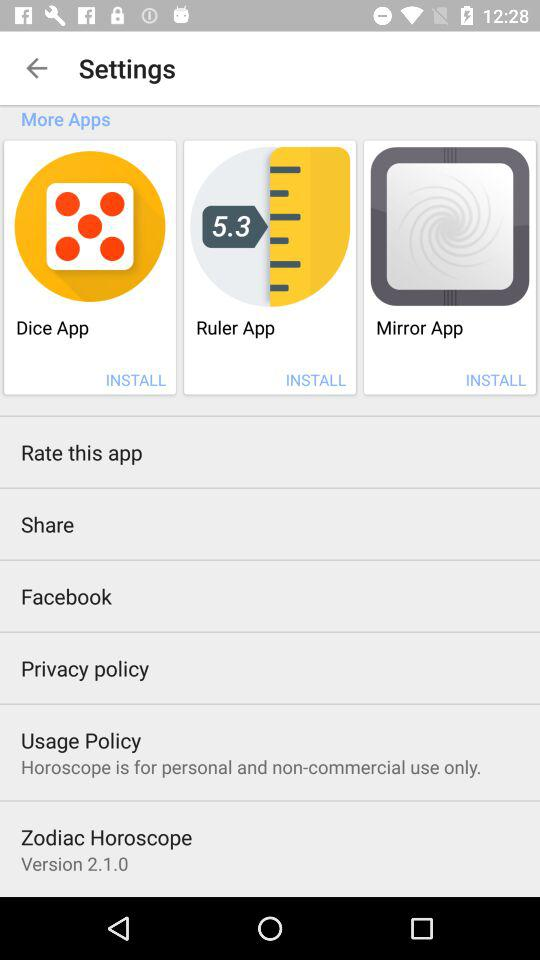What is the usage policy? The usage policy is "Horoscope is for personal and non-commercial use only.". 